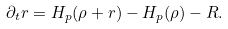<formula> <loc_0><loc_0><loc_500><loc_500>\partial _ { t } r = H _ { p } ( \rho + r ) - H _ { p } ( \rho ) - R .</formula> 